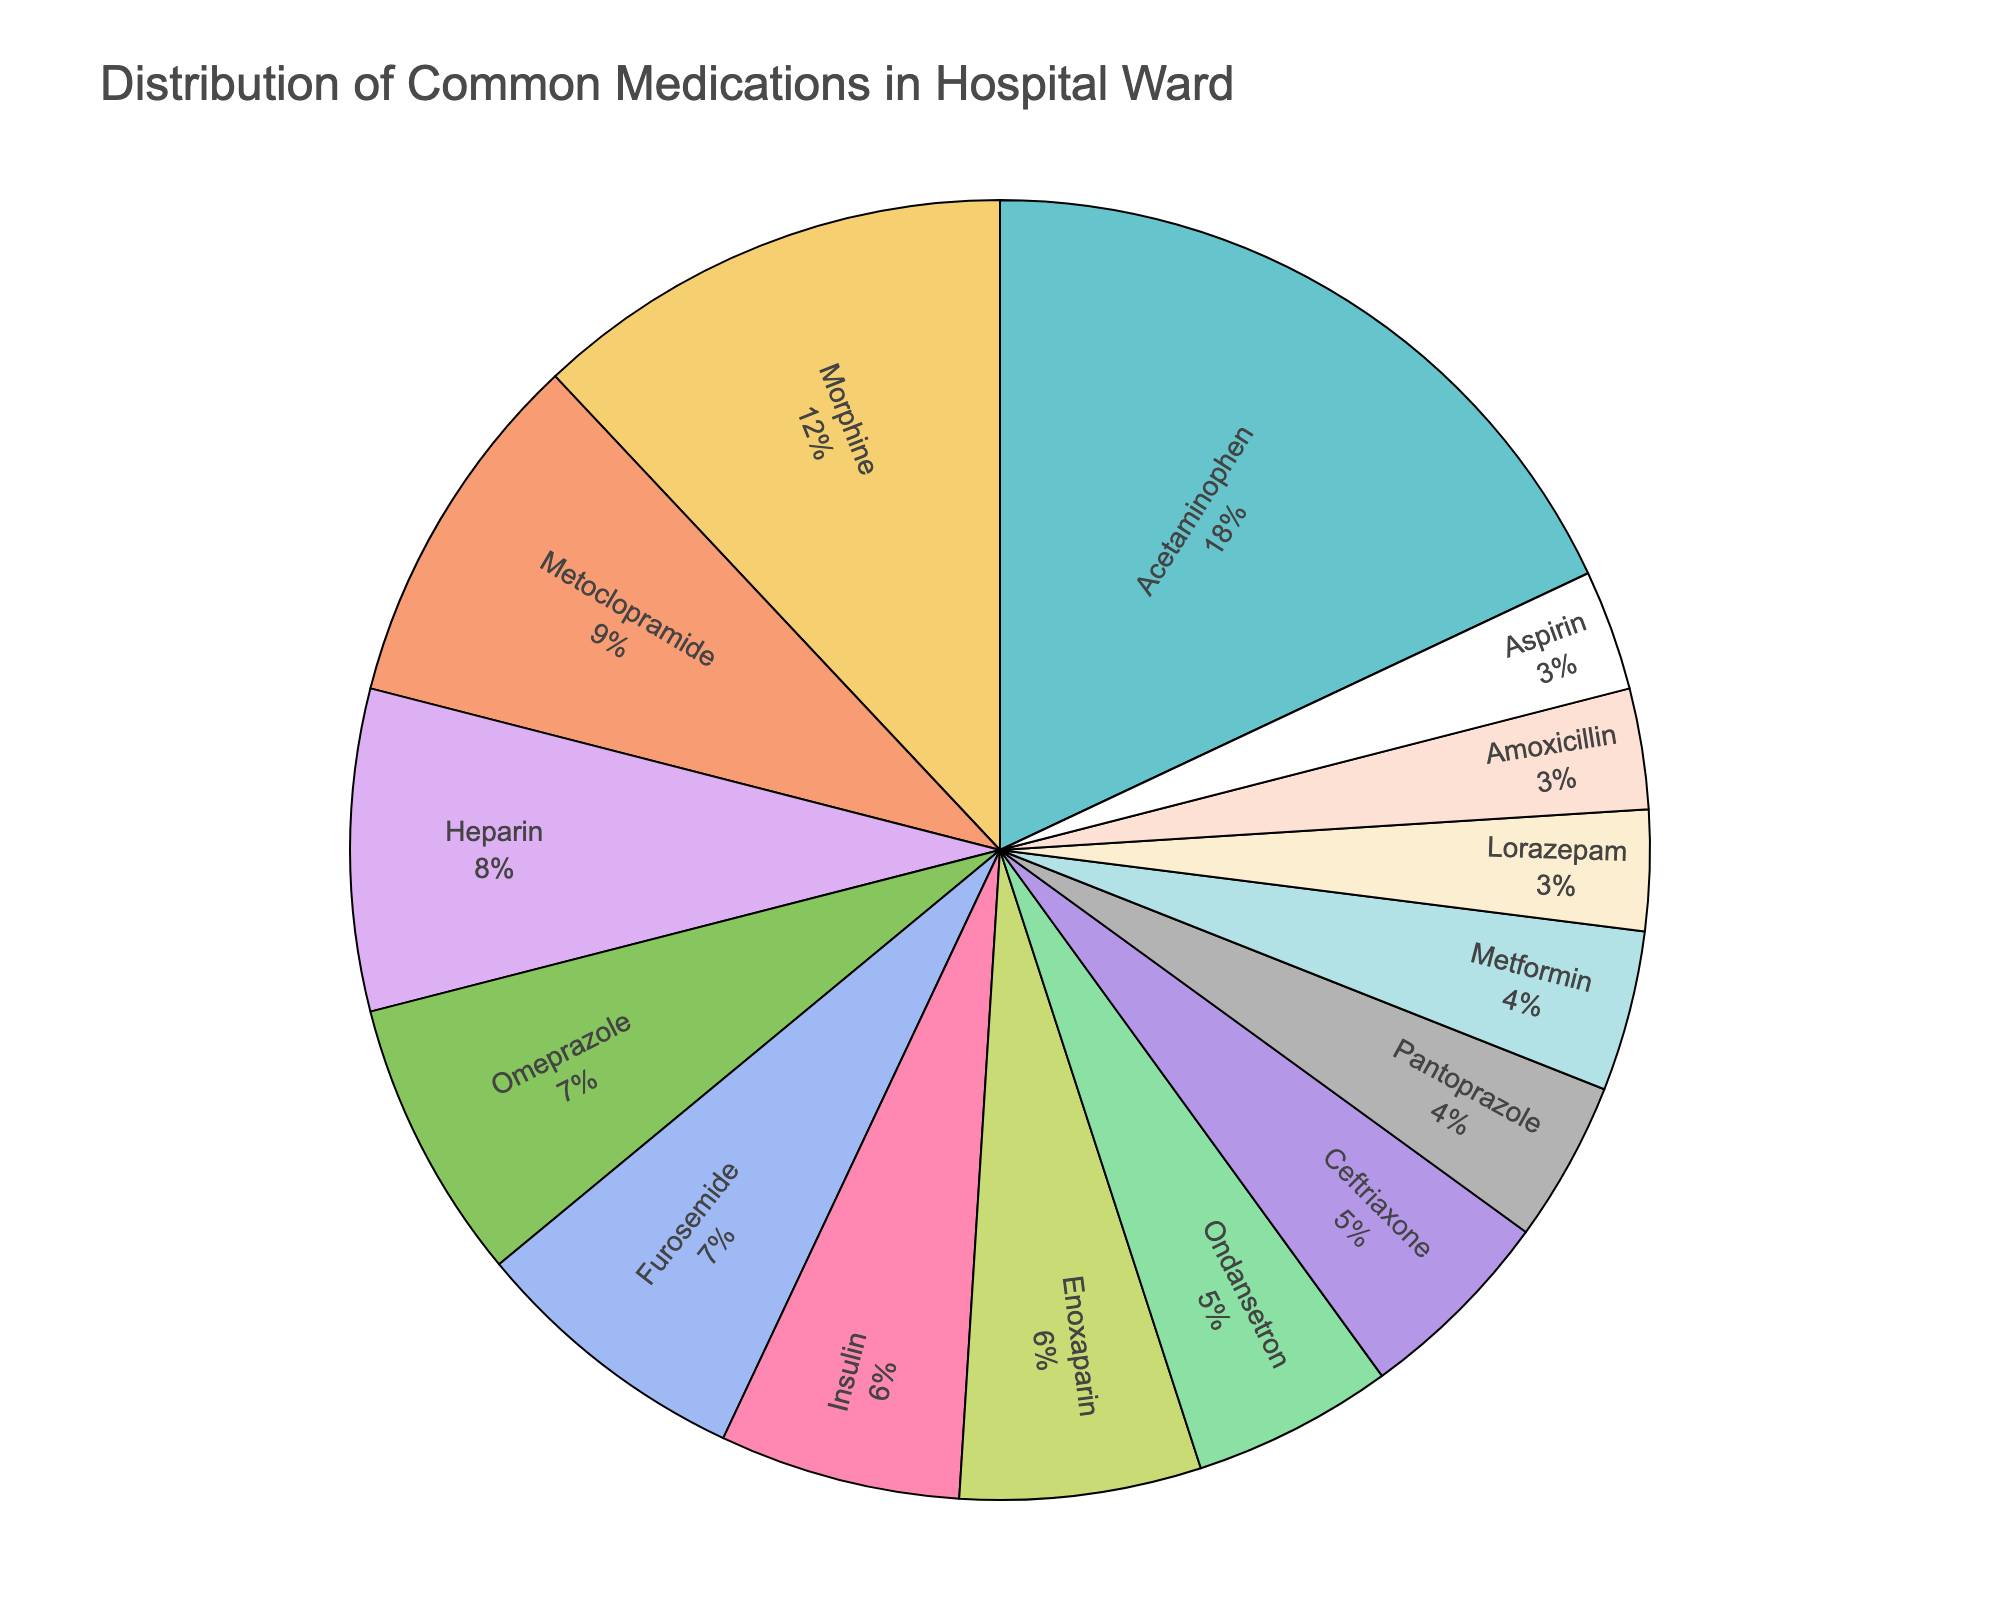What percentage of medications administered is Acetaminophen? Acetaminophen is represented in the pie chart with a segment labeled 'Acetaminophen', corresponding to 18%.
Answer: 18% Which medication has the smallest percentage of administration and what is it? The pie chart shows Amoxicillin, Aspirin, and Lorazepam each with a segment labeled 3%, which are the smallest percentages.
Answer: Amoxicillin, Aspirin, Lorazepam What is the total percentage of medications that are anti-emetics (Ondansetron and Metoclopramide)? Metoclopramide is 9% and Ondansetron is 5%. Adding these two percentages together gives 9% + 5% = 14%.
Answer: 14% Which has a larger percentage of administration: Morphine or Insulin? The pie chart shows Morphine with a segment labeled 12% and Insulin with 6%. Comparing these, Morphine has a larger percentage.
Answer: Morphine What is the combined percentage of insulin and enoxaparin administrations? Insulin is 6% and Enoxaparin is also 6%. Adding these together gives 6% + 6% = 12%.
Answer: 12% How much more is the percentage of Acetaminophen compared to Ceftriaxone? Acetaminophen is 18% and Ceftriaxone is 5%. The difference is 18% - 5% = 13%.
Answer: 13% Which medication has a higher administration percentage: Metformin or Pantoprazole? Pantoprazole has 4% and Metformin also has 4%, making them equal in administration percentage.
Answer: Neither; they are equal What is the total percentage for all medications with more than 6% administration? Adding up Acetaminophen (18%), Morphine (12%), Metoclopramide (9%), Heparin (8%), Omeprazole (7%), and Furosemide (7%) gives 18% + 12% + 9% + 8% + 7% + 7% = 61%.
Answer: 61% Are there more medications with exactly 3% administration or exactly 6% administration? The pie chart shows three medications with 3% each (Lorazepam, Amoxicillin, Aspirin) and two medications with 6% each (Insulin, Enoxaparin). Therefore, there are more medications with 3% administration.
Answer: 3% 